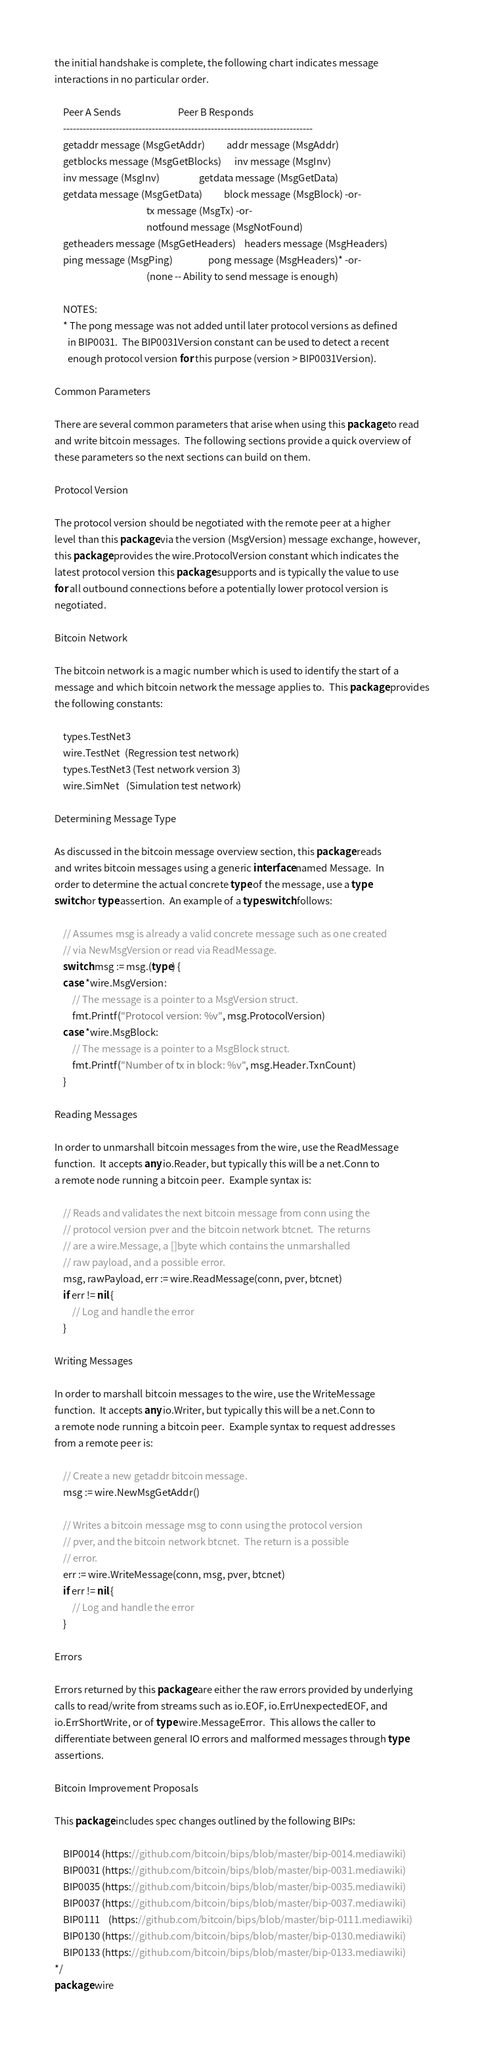<code> <loc_0><loc_0><loc_500><loc_500><_Go_>the initial handshake is complete, the following chart indicates message
interactions in no particular order.

	Peer A Sends                          Peer B Responds
	----------------------------------------------------------------------------
	getaddr message (MsgGetAddr)          addr message (MsgAddr)
	getblocks message (MsgGetBlocks)      inv message (MsgInv)
	inv message (MsgInv)                  getdata message (MsgGetData)
	getdata message (MsgGetData)          block message (MsgBlock) -or-
	                                      tx message (MsgTx) -or-
	                                      notfound message (MsgNotFound)
	getheaders message (MsgGetHeaders)    headers message (MsgHeaders)
	ping message (MsgPing)                pong message (MsgHeaders)* -or-
	                                      (none -- Ability to send message is enough)

	NOTES:
	* The pong message was not added until later protocol versions as defined
	  in BIP0031.  The BIP0031Version constant can be used to detect a recent
	  enough protocol version for this purpose (version > BIP0031Version).

Common Parameters

There are several common parameters that arise when using this package to read
and write bitcoin messages.  The following sections provide a quick overview of
these parameters so the next sections can build on them.

Protocol Version

The protocol version should be negotiated with the remote peer at a higher
level than this package via the version (MsgVersion) message exchange, however,
this package provides the wire.ProtocolVersion constant which indicates the
latest protocol version this package supports and is typically the value to use
for all outbound connections before a potentially lower protocol version is
negotiated.

Bitcoin Network

The bitcoin network is a magic number which is used to identify the start of a
message and which bitcoin network the message applies to.  This package provides
the following constants:

	types.TestNet3
	wire.TestNet  (Regression test network)
	types.TestNet3 (Test network version 3)
	wire.SimNet   (Simulation test network)

Determining Message Type

As discussed in the bitcoin message overview section, this package reads
and writes bitcoin messages using a generic interface named Message.  In
order to determine the actual concrete type of the message, use a type
switch or type assertion.  An example of a type switch follows:

	// Assumes msg is already a valid concrete message such as one created
	// via NewMsgVersion or read via ReadMessage.
	switch msg := msg.(type) {
	case *wire.MsgVersion:
		// The message is a pointer to a MsgVersion struct.
		fmt.Printf("Protocol version: %v", msg.ProtocolVersion)
	case *wire.MsgBlock:
		// The message is a pointer to a MsgBlock struct.
		fmt.Printf("Number of tx in block: %v", msg.Header.TxnCount)
	}

Reading Messages

In order to unmarshall bitcoin messages from the wire, use the ReadMessage
function.  It accepts any io.Reader, but typically this will be a net.Conn to
a remote node running a bitcoin peer.  Example syntax is:

	// Reads and validates the next bitcoin message from conn using the
	// protocol version pver and the bitcoin network btcnet.  The returns
	// are a wire.Message, a []byte which contains the unmarshalled
	// raw payload, and a possible error.
	msg, rawPayload, err := wire.ReadMessage(conn, pver, btcnet)
	if err != nil {
		// Log and handle the error
	}

Writing Messages

In order to marshall bitcoin messages to the wire, use the WriteMessage
function.  It accepts any io.Writer, but typically this will be a net.Conn to
a remote node running a bitcoin peer.  Example syntax to request addresses
from a remote peer is:

	// Create a new getaddr bitcoin message.
	msg := wire.NewMsgGetAddr()

	// Writes a bitcoin message msg to conn using the protocol version
	// pver, and the bitcoin network btcnet.  The return is a possible
	// error.
	err := wire.WriteMessage(conn, msg, pver, btcnet)
	if err != nil {
		// Log and handle the error
	}

Errors

Errors returned by this package are either the raw errors provided by underlying
calls to read/write from streams such as io.EOF, io.ErrUnexpectedEOF, and
io.ErrShortWrite, or of type wire.MessageError.  This allows the caller to
differentiate between general IO errors and malformed messages through type
assertions.

Bitcoin Improvement Proposals

This package includes spec changes outlined by the following BIPs:

	BIP0014 (https://github.com/bitcoin/bips/blob/master/bip-0014.mediawiki)
	BIP0031 (https://github.com/bitcoin/bips/blob/master/bip-0031.mediawiki)
	BIP0035 (https://github.com/bitcoin/bips/blob/master/bip-0035.mediawiki)
	BIP0037 (https://github.com/bitcoin/bips/blob/master/bip-0037.mediawiki)
	BIP0111	(https://github.com/bitcoin/bips/blob/master/bip-0111.mediawiki)
	BIP0130 (https://github.com/bitcoin/bips/blob/master/bip-0130.mediawiki)
	BIP0133 (https://github.com/bitcoin/bips/blob/master/bip-0133.mediawiki)
*/
package wire
</code> 